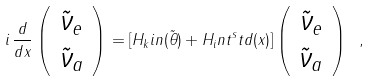Convert formula to latex. <formula><loc_0><loc_0><loc_500><loc_500>i \, \frac { d } { d x } \left ( \begin{array} { c } \tilde { \nu } _ { e } \\ \tilde { \nu } _ { a } \end{array} \right ) = [ H _ { k } i n ( \tilde { \theta } ) + H _ { i } n t ^ { s } t d ( x ) ] \left ( \begin{array} { c } \tilde { \nu } _ { e } \\ \tilde { \nu } _ { a } \end{array} \right ) \ ,</formula> 